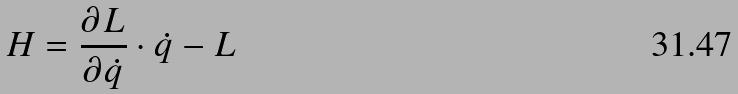<formula> <loc_0><loc_0><loc_500><loc_500>H = \frac { \partial L } { \partial \dot { q } } \cdot \dot { q } - L</formula> 